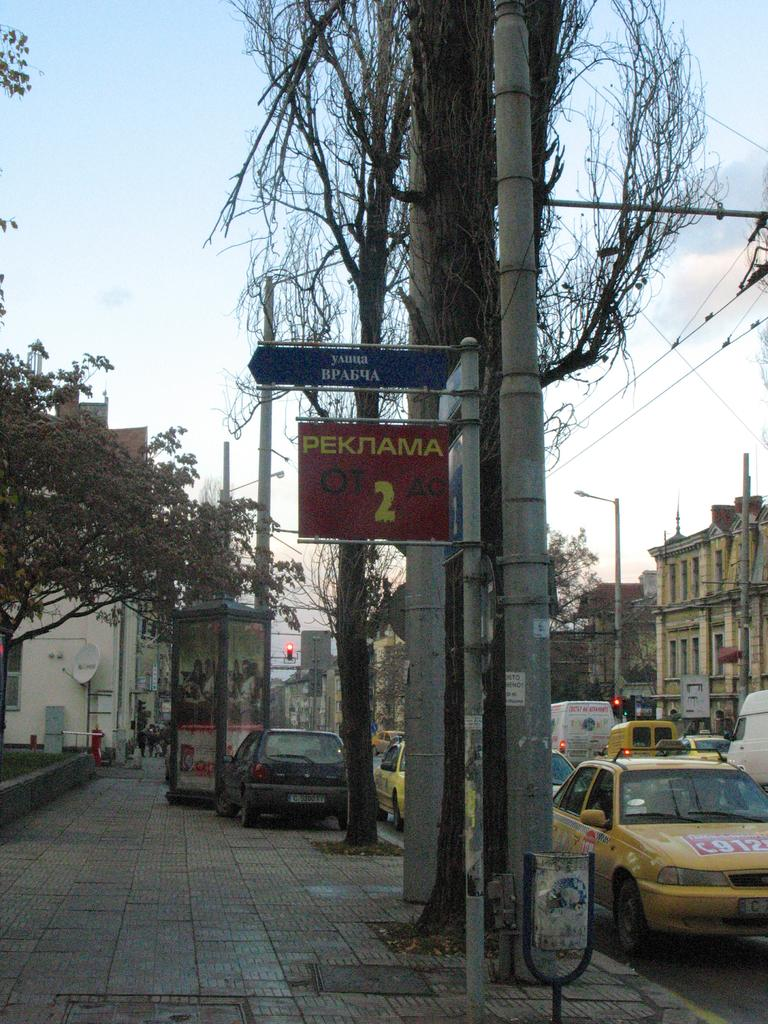<image>
Provide a brief description of the given image. A red sign that says Peknama on it with the number 2. 